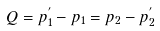Convert formula to latex. <formula><loc_0><loc_0><loc_500><loc_500>Q = p _ { 1 } ^ { ^ { \prime } } - p _ { 1 } = p _ { 2 } - p _ { 2 } ^ { ^ { \prime } }</formula> 